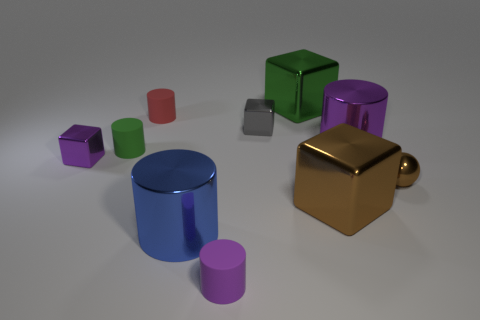How many brown objects have the same material as the big blue cylinder? 2 